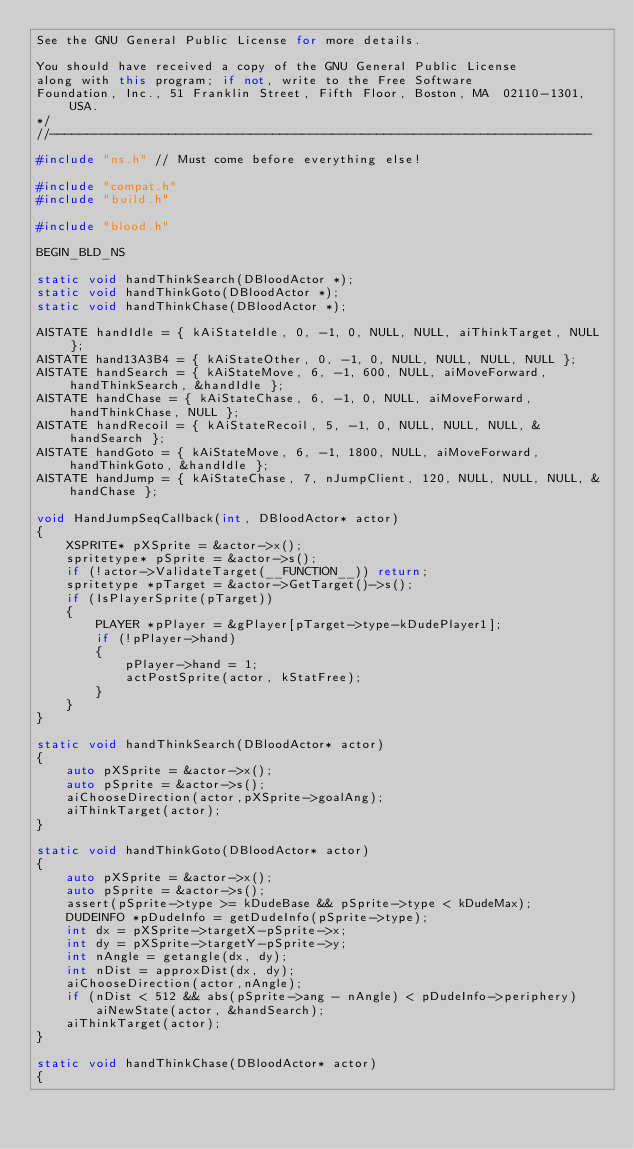Convert code to text. <code><loc_0><loc_0><loc_500><loc_500><_C++_>See the GNU General Public License for more details.

You should have received a copy of the GNU General Public License
along with this program; if not, write to the Free Software
Foundation, Inc., 51 Franklin Street, Fifth Floor, Boston, MA  02110-1301, USA.
*/
//-------------------------------------------------------------------------

#include "ns.h"	// Must come before everything else!

#include "compat.h"
#include "build.h"

#include "blood.h"

BEGIN_BLD_NS

static void handThinkSearch(DBloodActor *);
static void handThinkGoto(DBloodActor *);
static void handThinkChase(DBloodActor *);

AISTATE handIdle = { kAiStateIdle, 0, -1, 0, NULL, NULL, aiThinkTarget, NULL };
AISTATE hand13A3B4 = { kAiStateOther, 0, -1, 0, NULL, NULL, NULL, NULL };
AISTATE handSearch = { kAiStateMove, 6, -1, 600, NULL, aiMoveForward, handThinkSearch, &handIdle };
AISTATE handChase = { kAiStateChase, 6, -1, 0, NULL, aiMoveForward, handThinkChase, NULL };
AISTATE handRecoil = { kAiStateRecoil, 5, -1, 0, NULL, NULL, NULL, &handSearch };
AISTATE handGoto = { kAiStateMove, 6, -1, 1800, NULL, aiMoveForward, handThinkGoto, &handIdle };
AISTATE handJump = { kAiStateChase, 7, nJumpClient, 120, NULL, NULL, NULL, &handChase };

void HandJumpSeqCallback(int, DBloodActor* actor)
{
    XSPRITE* pXSprite = &actor->x();
    spritetype* pSprite = &actor->s();
    if (!actor->ValidateTarget(__FUNCTION__)) return;
    spritetype *pTarget = &actor->GetTarget()->s();
    if (IsPlayerSprite(pTarget))
    {
        PLAYER *pPlayer = &gPlayer[pTarget->type-kDudePlayer1];
        if (!pPlayer->hand)
        {
            pPlayer->hand = 1;
            actPostSprite(actor, kStatFree);
        }
    }
}

static void handThinkSearch(DBloodActor* actor)
{
    auto pXSprite = &actor->x();
    auto pSprite = &actor->s();
    aiChooseDirection(actor,pXSprite->goalAng);
    aiThinkTarget(actor);
}

static void handThinkGoto(DBloodActor* actor)
{
    auto pXSprite = &actor->x();
    auto pSprite = &actor->s();
    assert(pSprite->type >= kDudeBase && pSprite->type < kDudeMax);
    DUDEINFO *pDudeInfo = getDudeInfo(pSprite->type);
    int dx = pXSprite->targetX-pSprite->x;
    int dy = pXSprite->targetY-pSprite->y;
    int nAngle = getangle(dx, dy);
    int nDist = approxDist(dx, dy);
    aiChooseDirection(actor,nAngle);
    if (nDist < 512 && abs(pSprite->ang - nAngle) < pDudeInfo->periphery)
        aiNewState(actor, &handSearch);
    aiThinkTarget(actor);
}

static void handThinkChase(DBloodActor* actor)
{</code> 